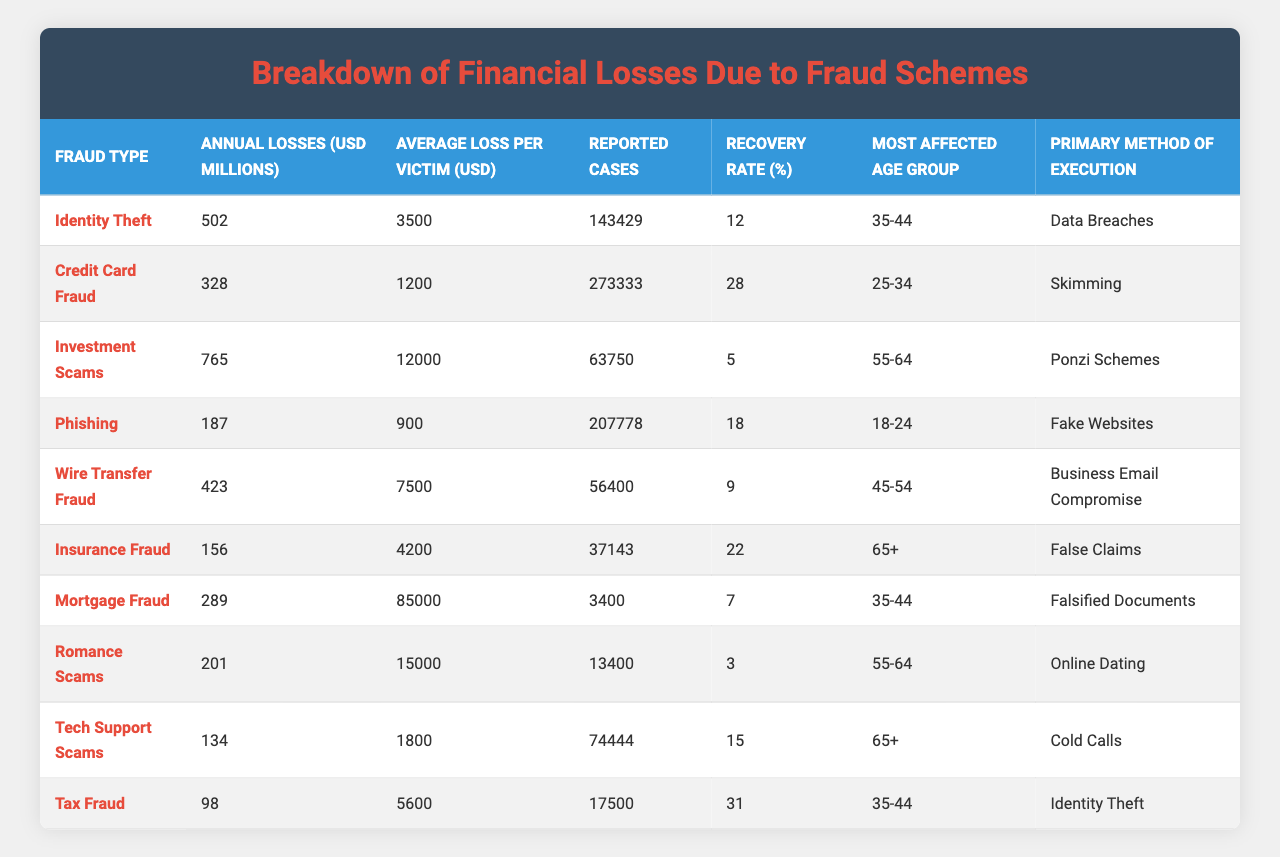What is the fraud type with the highest annual losses? By examining the "Annual Losses (USD Millions)" column, it shows "Investment Scams" with losses of 765 million USD, which is higher than all other fraud types.
Answer: Investment Scams Which fraud type has the lowest recovery rate? The "Recovery Rate (%)" column indicates that "Romance Scams" has the lowest recovery rate at 3%.
Answer: 3% How many reported cases of Credit Card Fraud are there? Referring to the "Reported Cases" column, "Credit Card Fraud" has 273,333 reported cases listed.
Answer: 273,333 What is the average loss per victim for Identity Theft? Looking at the "Average Loss per Victim (USD)" column, the value associated with "Identity Theft" is 3,500 USD.
Answer: 3,500 USD Which fraud type has both the highest average loss per victim and high annual losses? "Investment Scams" has an average loss per victim of 12,000 USD, along with the highest annual losses of 765 million USD, indicating it is significantly impactful for those affected.
Answer: Investment Scams What is the total annual loss across all fraud types? By summing the values in the "Annual Losses (USD Millions)" column (502 + 328 + 765 + 187 + 423 + 156 + 289 + 201 + 134 + 98), we get a total of 2,580 million USD.
Answer: 2,580 million USD Is there a fraud type with a recovery rate above 30%? Checking the "Recovery Rate (%)" column, "Tax Fraud" has a recovery rate of 31%, confirming that yes, there is a fraud type with a rate above 30%.
Answer: Yes Which age group is most affected by Insurance Fraud? Referring to the "Most Affected Age Group" column for "Insurance Fraud," the data shows the age group as "65+".
Answer: 65+ If a victim suffers from Wire Transfer Fraud, what is the average loss they face? According to the "Average Loss per Victim (USD)" for "Wire Transfer Fraud," the average loss is 7,500 USD.
Answer: 7,500 USD What is the average recovery rate for fraud types affecting the age group 35-44? The fraud types affecting this age group include "Identity Theft," "Mortgage Fraud," and "Tax Fraud," with recovery rates of 12%, 7%, and 31%, respectively. The average is (12 + 7 + 31) / 3 = 16.67%.
Answer: 16.67% How does the primary method of execution differ between Romance Scams and Investment Scams? "Romance Scams" primarily uses "Online Dating," while "Investment Scams" utilize "Ponzi Schemes," showing that the execution methods are very different concerning their context and approach.
Answer: They differ in methods; "Online Dating" vs "Ponzi Schemes" 